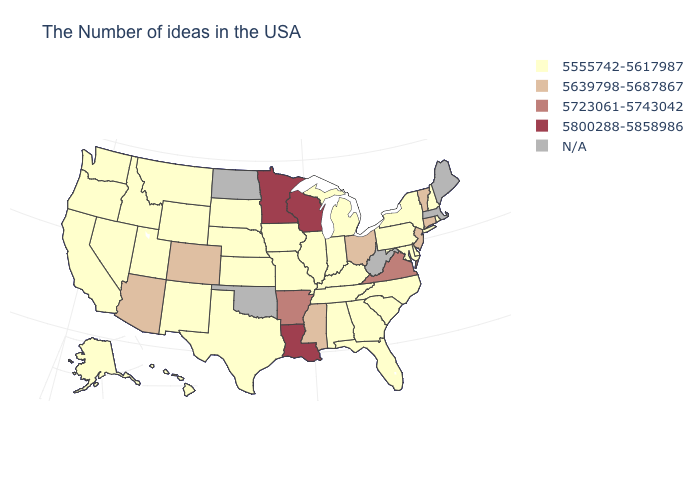What is the value of Maine?
Answer briefly. N/A. Name the states that have a value in the range N/A?
Be succinct. Maine, Massachusetts, West Virginia, Oklahoma, North Dakota. Does Nebraska have the lowest value in the MidWest?
Concise answer only. Yes. What is the value of Oklahoma?
Give a very brief answer. N/A. What is the lowest value in the USA?
Quick response, please. 5555742-5617987. Which states hav the highest value in the West?
Give a very brief answer. Colorado, Arizona. Is the legend a continuous bar?
Keep it brief. No. Which states hav the highest value in the West?
Concise answer only. Colorado, Arizona. Among the states that border Vermont , which have the lowest value?
Concise answer only. New Hampshire, New York. What is the value of Nevada?
Answer briefly. 5555742-5617987. Name the states that have a value in the range 5639798-5687867?
Answer briefly. Vermont, Connecticut, New Jersey, Ohio, Mississippi, Colorado, Arizona. Does Rhode Island have the highest value in the USA?
Concise answer only. No. Name the states that have a value in the range 5639798-5687867?
Answer briefly. Vermont, Connecticut, New Jersey, Ohio, Mississippi, Colorado, Arizona. Which states hav the highest value in the West?
Quick response, please. Colorado, Arizona. 